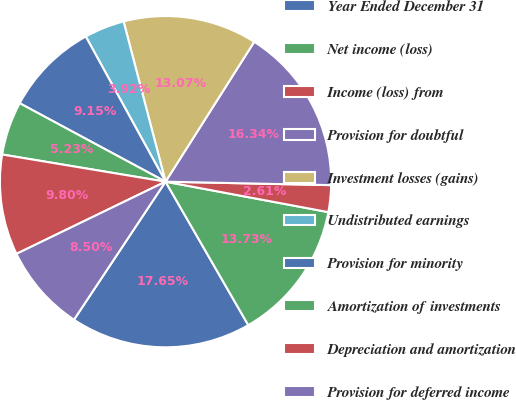Convert chart to OTSL. <chart><loc_0><loc_0><loc_500><loc_500><pie_chart><fcel>Year Ended December 31<fcel>Net income (loss)<fcel>Income (loss) from<fcel>Provision for doubtful<fcel>Investment losses (gains)<fcel>Undistributed earnings<fcel>Provision for minority<fcel>Amortization of investments<fcel>Depreciation and amortization<fcel>Provision for deferred income<nl><fcel>17.65%<fcel>13.73%<fcel>2.61%<fcel>16.34%<fcel>13.07%<fcel>3.92%<fcel>9.15%<fcel>5.23%<fcel>9.8%<fcel>8.5%<nl></chart> 